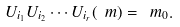<formula> <loc_0><loc_0><loc_500><loc_500>U _ { i _ { 1 } } U _ { i _ { 2 } } \cdots U _ { i _ { r } } ( \ m ) = \ m _ { 0 } .</formula> 